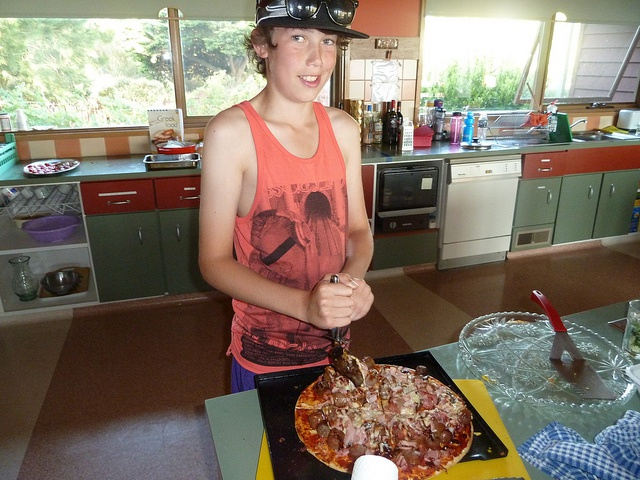Describe the objects in this image and their specific colors. I can see dining table in gray, black, and maroon tones, people in gray, brown, tan, salmon, and maroon tones, pizza in gray, maroon, brown, and tan tones, bowl in gray and darkgray tones, and microwave in gray, black, and darkgray tones in this image. 